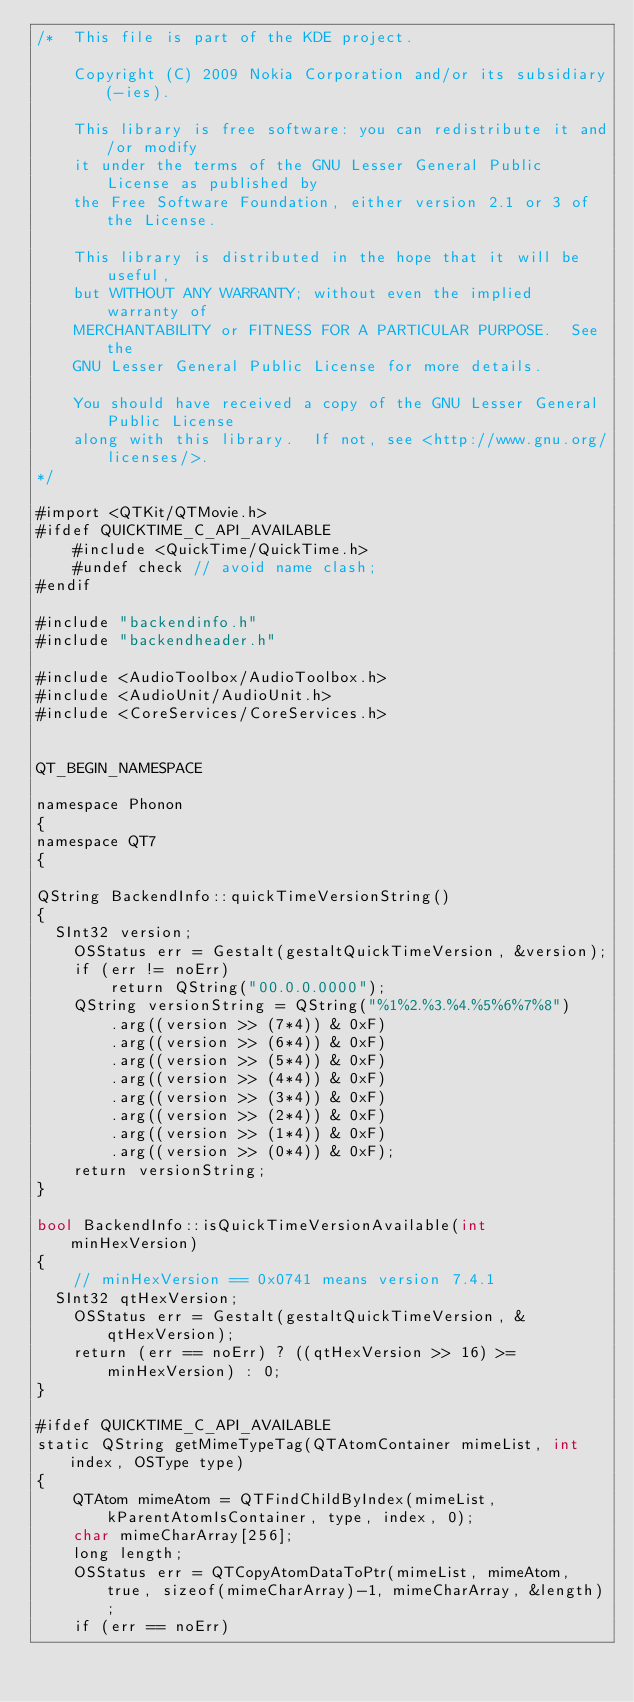Convert code to text. <code><loc_0><loc_0><loc_500><loc_500><_ObjectiveC_>/*  This file is part of the KDE project.

    Copyright (C) 2009 Nokia Corporation and/or its subsidiary(-ies).

    This library is free software: you can redistribute it and/or modify
    it under the terms of the GNU Lesser General Public License as published by
    the Free Software Foundation, either version 2.1 or 3 of the License.

    This library is distributed in the hope that it will be useful,
    but WITHOUT ANY WARRANTY; without even the implied warranty of
    MERCHANTABILITY or FITNESS FOR A PARTICULAR PURPOSE.  See the
    GNU Lesser General Public License for more details.

    You should have received a copy of the GNU Lesser General Public License
    along with this library.  If not, see <http://www.gnu.org/licenses/>.
*/

#import <QTKit/QTMovie.h>
#ifdef QUICKTIME_C_API_AVAILABLE
    #include <QuickTime/QuickTime.h>
    #undef check // avoid name clash;
#endif

#include "backendinfo.h"
#include "backendheader.h"

#include <AudioToolbox/AudioToolbox.h>
#include <AudioUnit/AudioUnit.h>
#include <CoreServices/CoreServices.h>


QT_BEGIN_NAMESPACE

namespace Phonon
{
namespace QT7
{

QString BackendInfo::quickTimeVersionString()
{
	SInt32 version;
    OSStatus err = Gestalt(gestaltQuickTimeVersion, &version);
    if (err != noErr)
        return QString("00.0.0.0000");
    QString versionString = QString("%1%2.%3.%4.%5%6%7%8")
        .arg((version >> (7*4)) & 0xF)
        .arg((version >> (6*4)) & 0xF)
        .arg((version >> (5*4)) & 0xF)
        .arg((version >> (4*4)) & 0xF)
        .arg((version >> (3*4)) & 0xF)
        .arg((version >> (2*4)) & 0xF)
        .arg((version >> (1*4)) & 0xF)
        .arg((version >> (0*4)) & 0xF);
    return versionString;
}

bool BackendInfo::isQuickTimeVersionAvailable(int minHexVersion)
{
    // minHexVersion == 0x0741 means version 7.4.1
	SInt32 qtHexVersion;
    OSStatus err = Gestalt(gestaltQuickTimeVersion, &qtHexVersion);
    return (err == noErr) ? ((qtHexVersion >> 16) >= minHexVersion) : 0;
}

#ifdef QUICKTIME_C_API_AVAILABLE
static QString getMimeTypeTag(QTAtomContainer mimeList, int index, OSType type)
{
    QTAtom mimeAtom = QTFindChildByIndex(mimeList, kParentAtomIsContainer, type, index, 0);
    char mimeCharArray[256];
    long length;
    OSStatus err = QTCopyAtomDataToPtr(mimeList, mimeAtom, true, sizeof(mimeCharArray)-1, mimeCharArray, &length);
    if (err == noErr)</code> 